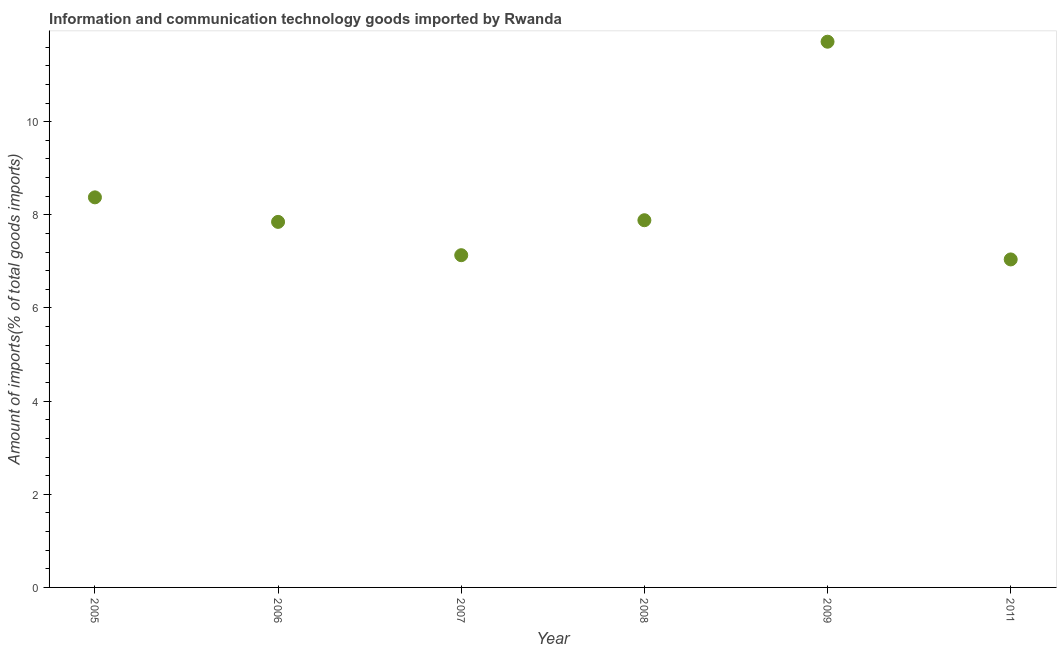What is the amount of ict goods imports in 2006?
Provide a short and direct response. 7.85. Across all years, what is the maximum amount of ict goods imports?
Offer a very short reply. 11.72. Across all years, what is the minimum amount of ict goods imports?
Offer a terse response. 7.04. In which year was the amount of ict goods imports minimum?
Your response must be concise. 2011. What is the sum of the amount of ict goods imports?
Offer a very short reply. 50. What is the difference between the amount of ict goods imports in 2007 and 2008?
Your answer should be very brief. -0.75. What is the average amount of ict goods imports per year?
Provide a succinct answer. 8.33. What is the median amount of ict goods imports?
Offer a terse response. 7.87. Do a majority of the years between 2005 and 2006 (inclusive) have amount of ict goods imports greater than 6 %?
Provide a short and direct response. Yes. What is the ratio of the amount of ict goods imports in 2006 to that in 2011?
Offer a very short reply. 1.11. Is the difference between the amount of ict goods imports in 2008 and 2011 greater than the difference between any two years?
Make the answer very short. No. What is the difference between the highest and the second highest amount of ict goods imports?
Keep it short and to the point. 3.34. Is the sum of the amount of ict goods imports in 2007 and 2011 greater than the maximum amount of ict goods imports across all years?
Your answer should be very brief. Yes. What is the difference between the highest and the lowest amount of ict goods imports?
Provide a short and direct response. 4.67. Does the amount of ict goods imports monotonically increase over the years?
Keep it short and to the point. No. How many years are there in the graph?
Keep it short and to the point. 6. Does the graph contain any zero values?
Offer a terse response. No. Does the graph contain grids?
Make the answer very short. No. What is the title of the graph?
Your answer should be very brief. Information and communication technology goods imported by Rwanda. What is the label or title of the X-axis?
Keep it short and to the point. Year. What is the label or title of the Y-axis?
Provide a succinct answer. Amount of imports(% of total goods imports). What is the Amount of imports(% of total goods imports) in 2005?
Offer a terse response. 8.38. What is the Amount of imports(% of total goods imports) in 2006?
Your answer should be compact. 7.85. What is the Amount of imports(% of total goods imports) in 2007?
Offer a very short reply. 7.13. What is the Amount of imports(% of total goods imports) in 2008?
Give a very brief answer. 7.88. What is the Amount of imports(% of total goods imports) in 2009?
Your response must be concise. 11.72. What is the Amount of imports(% of total goods imports) in 2011?
Give a very brief answer. 7.04. What is the difference between the Amount of imports(% of total goods imports) in 2005 and 2006?
Your answer should be very brief. 0.53. What is the difference between the Amount of imports(% of total goods imports) in 2005 and 2007?
Your answer should be compact. 1.24. What is the difference between the Amount of imports(% of total goods imports) in 2005 and 2008?
Offer a very short reply. 0.49. What is the difference between the Amount of imports(% of total goods imports) in 2005 and 2009?
Offer a terse response. -3.34. What is the difference between the Amount of imports(% of total goods imports) in 2005 and 2011?
Make the answer very short. 1.33. What is the difference between the Amount of imports(% of total goods imports) in 2006 and 2007?
Your answer should be very brief. 0.72. What is the difference between the Amount of imports(% of total goods imports) in 2006 and 2008?
Provide a succinct answer. -0.04. What is the difference between the Amount of imports(% of total goods imports) in 2006 and 2009?
Offer a very short reply. -3.87. What is the difference between the Amount of imports(% of total goods imports) in 2006 and 2011?
Give a very brief answer. 0.81. What is the difference between the Amount of imports(% of total goods imports) in 2007 and 2008?
Make the answer very short. -0.75. What is the difference between the Amount of imports(% of total goods imports) in 2007 and 2009?
Offer a terse response. -4.58. What is the difference between the Amount of imports(% of total goods imports) in 2007 and 2011?
Ensure brevity in your answer.  0.09. What is the difference between the Amount of imports(% of total goods imports) in 2008 and 2009?
Your answer should be very brief. -3.83. What is the difference between the Amount of imports(% of total goods imports) in 2008 and 2011?
Ensure brevity in your answer.  0.84. What is the difference between the Amount of imports(% of total goods imports) in 2009 and 2011?
Offer a very short reply. 4.67. What is the ratio of the Amount of imports(% of total goods imports) in 2005 to that in 2006?
Provide a succinct answer. 1.07. What is the ratio of the Amount of imports(% of total goods imports) in 2005 to that in 2007?
Keep it short and to the point. 1.17. What is the ratio of the Amount of imports(% of total goods imports) in 2005 to that in 2008?
Ensure brevity in your answer.  1.06. What is the ratio of the Amount of imports(% of total goods imports) in 2005 to that in 2009?
Ensure brevity in your answer.  0.71. What is the ratio of the Amount of imports(% of total goods imports) in 2005 to that in 2011?
Provide a short and direct response. 1.19. What is the ratio of the Amount of imports(% of total goods imports) in 2006 to that in 2007?
Offer a terse response. 1.1. What is the ratio of the Amount of imports(% of total goods imports) in 2006 to that in 2009?
Provide a succinct answer. 0.67. What is the ratio of the Amount of imports(% of total goods imports) in 2006 to that in 2011?
Your answer should be very brief. 1.11. What is the ratio of the Amount of imports(% of total goods imports) in 2007 to that in 2008?
Offer a very short reply. 0.91. What is the ratio of the Amount of imports(% of total goods imports) in 2007 to that in 2009?
Provide a succinct answer. 0.61. What is the ratio of the Amount of imports(% of total goods imports) in 2008 to that in 2009?
Provide a succinct answer. 0.67. What is the ratio of the Amount of imports(% of total goods imports) in 2008 to that in 2011?
Provide a succinct answer. 1.12. What is the ratio of the Amount of imports(% of total goods imports) in 2009 to that in 2011?
Offer a terse response. 1.66. 